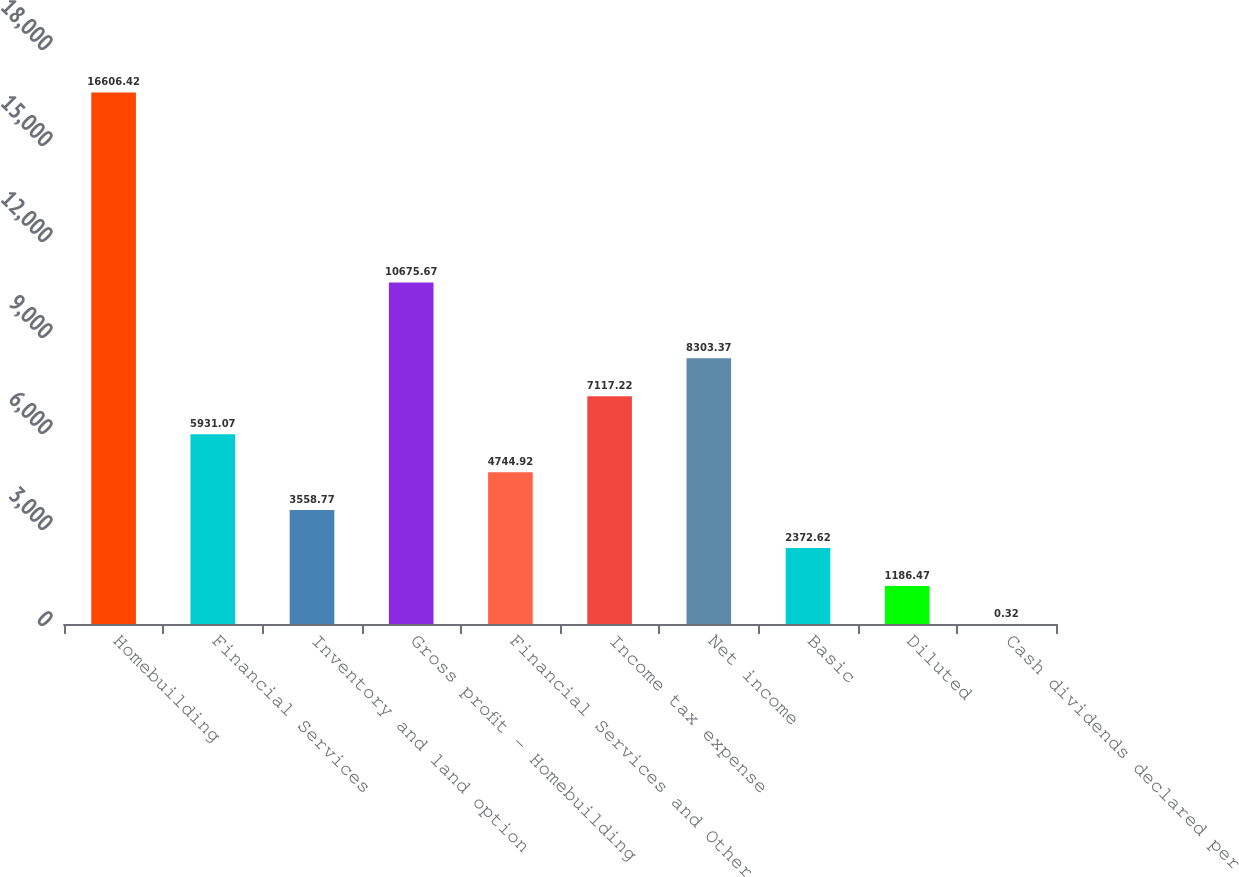Convert chart. <chart><loc_0><loc_0><loc_500><loc_500><bar_chart><fcel>Homebuilding<fcel>Financial Services<fcel>Inventory and land option<fcel>Gross profit - Homebuilding<fcel>Financial Services and Other<fcel>Income tax expense<fcel>Net income<fcel>Basic<fcel>Diluted<fcel>Cash dividends declared per<nl><fcel>16606.4<fcel>5931.07<fcel>3558.77<fcel>10675.7<fcel>4744.92<fcel>7117.22<fcel>8303.37<fcel>2372.62<fcel>1186.47<fcel>0.32<nl></chart> 